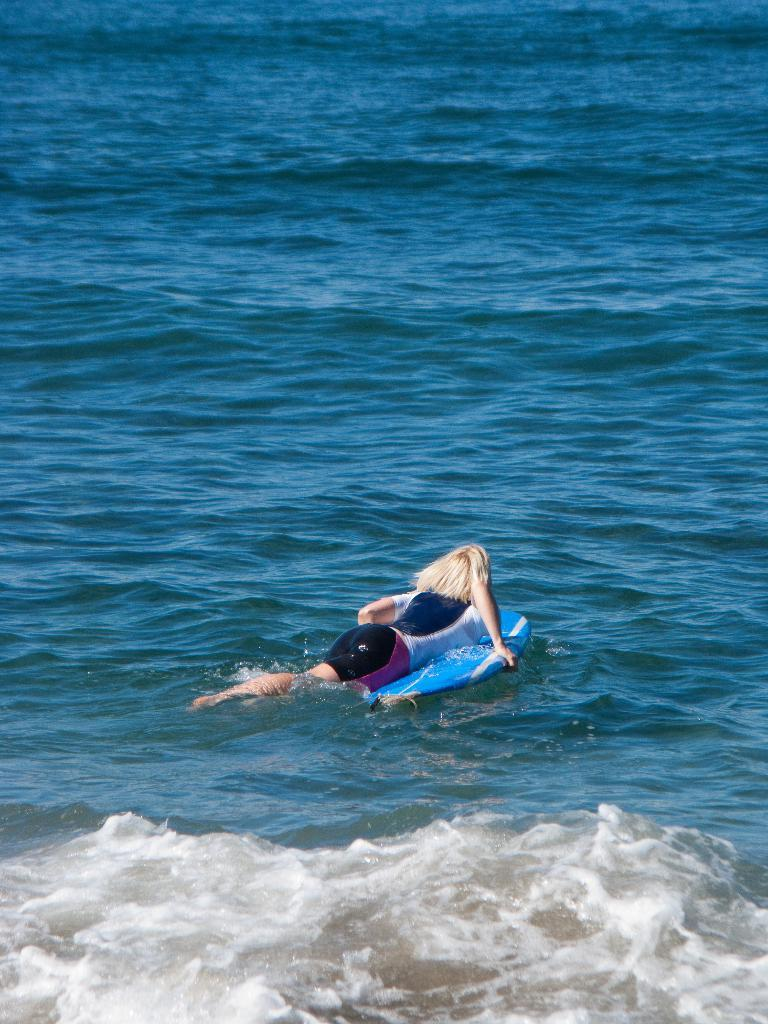What object is visible in the image that is used for surfing? There is a surfboard in the image. Where is the surfboard located in the image? The surfboard is on the water. Is there anyone using the surfboard in the image? Yes, there is a person on the surfboard. How many chickens can be seen in the image? There are no chickens present in the image. 